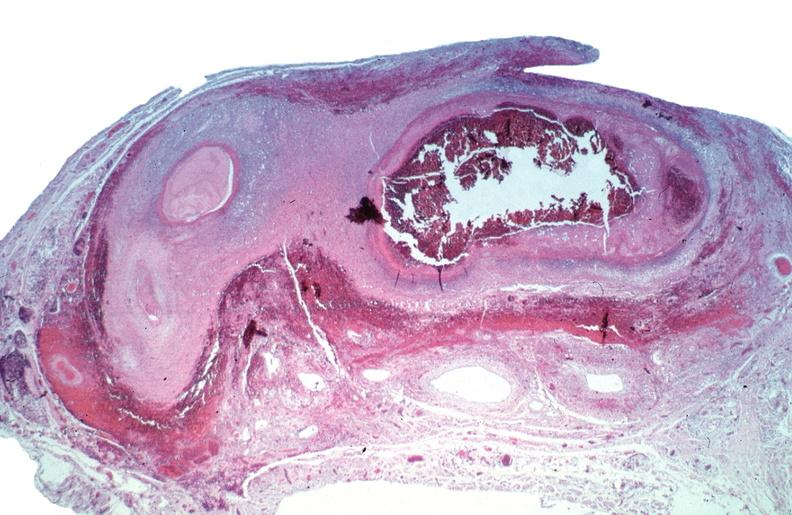does nodular tumor show vasculitis, polyarteritis nodosa?
Answer the question using a single word or phrase. No 